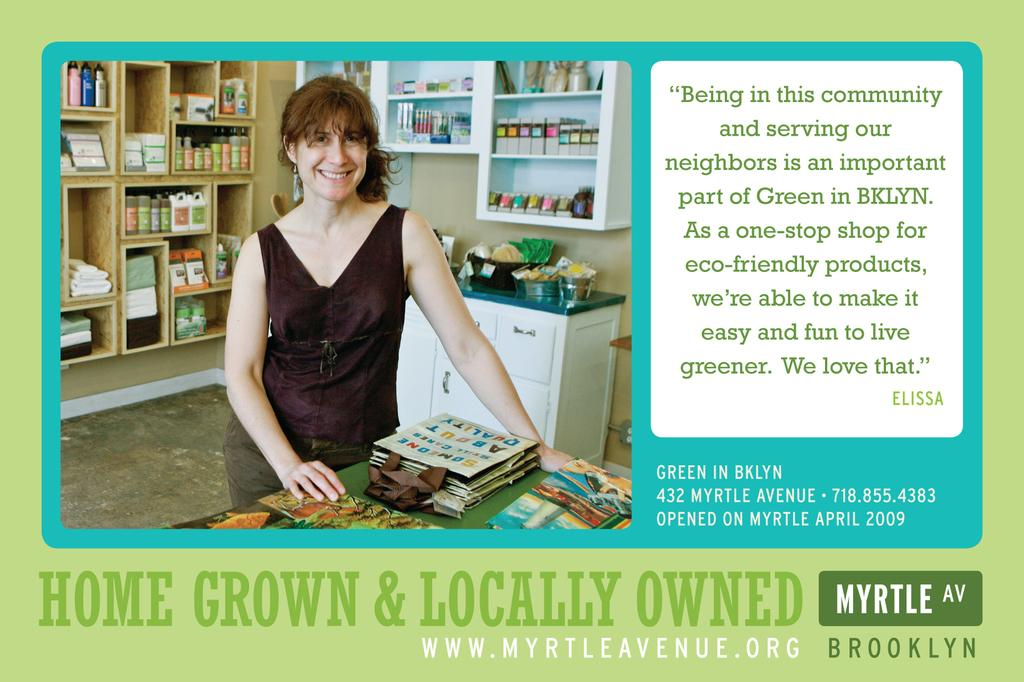Who is the main subject in the image? There is a woman in the image. What is the woman wearing? The woman is wearing a black dress. What is the woman doing in the image? The woman is standing. What can be seen behind the woman? There are objects behind the woman. What additional information is provided with the image? There is text written beside and below the image. What type of impulse is the woman experiencing in the image? There is no indication of any impulse being experienced by the woman in the image. What scientific theory is the woman discussing in the image? There is no indication of any scientific discussion or theory in the image. 